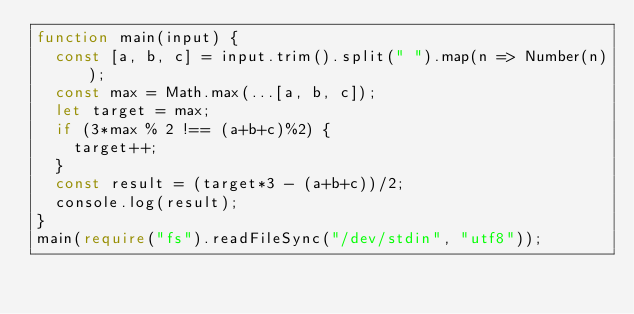Convert code to text. <code><loc_0><loc_0><loc_500><loc_500><_TypeScript_>function main(input) {
  const [a, b, c] = input.trim().split(" ").map(n => Number(n));
  const max = Math.max(...[a, b, c]);
  let target = max;
  if (3*max % 2 !== (a+b+c)%2) {
    target++;
  }
  const result = (target*3 - (a+b+c))/2;
  console.log(result);
}
main(require("fs").readFileSync("/dev/stdin", "utf8"));
</code> 